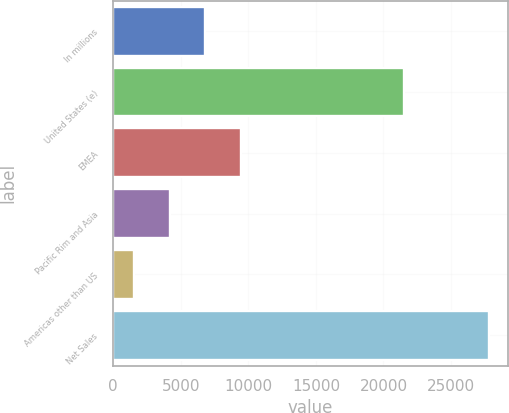Convert chart. <chart><loc_0><loc_0><loc_500><loc_500><bar_chart><fcel>In millions<fcel>United States (e)<fcel>EMEA<fcel>Pacific Rim and Asia<fcel>Americas other than US<fcel>Net Sales<nl><fcel>6813.8<fcel>21523<fcel>9441.2<fcel>4186.4<fcel>1559<fcel>27833<nl></chart> 